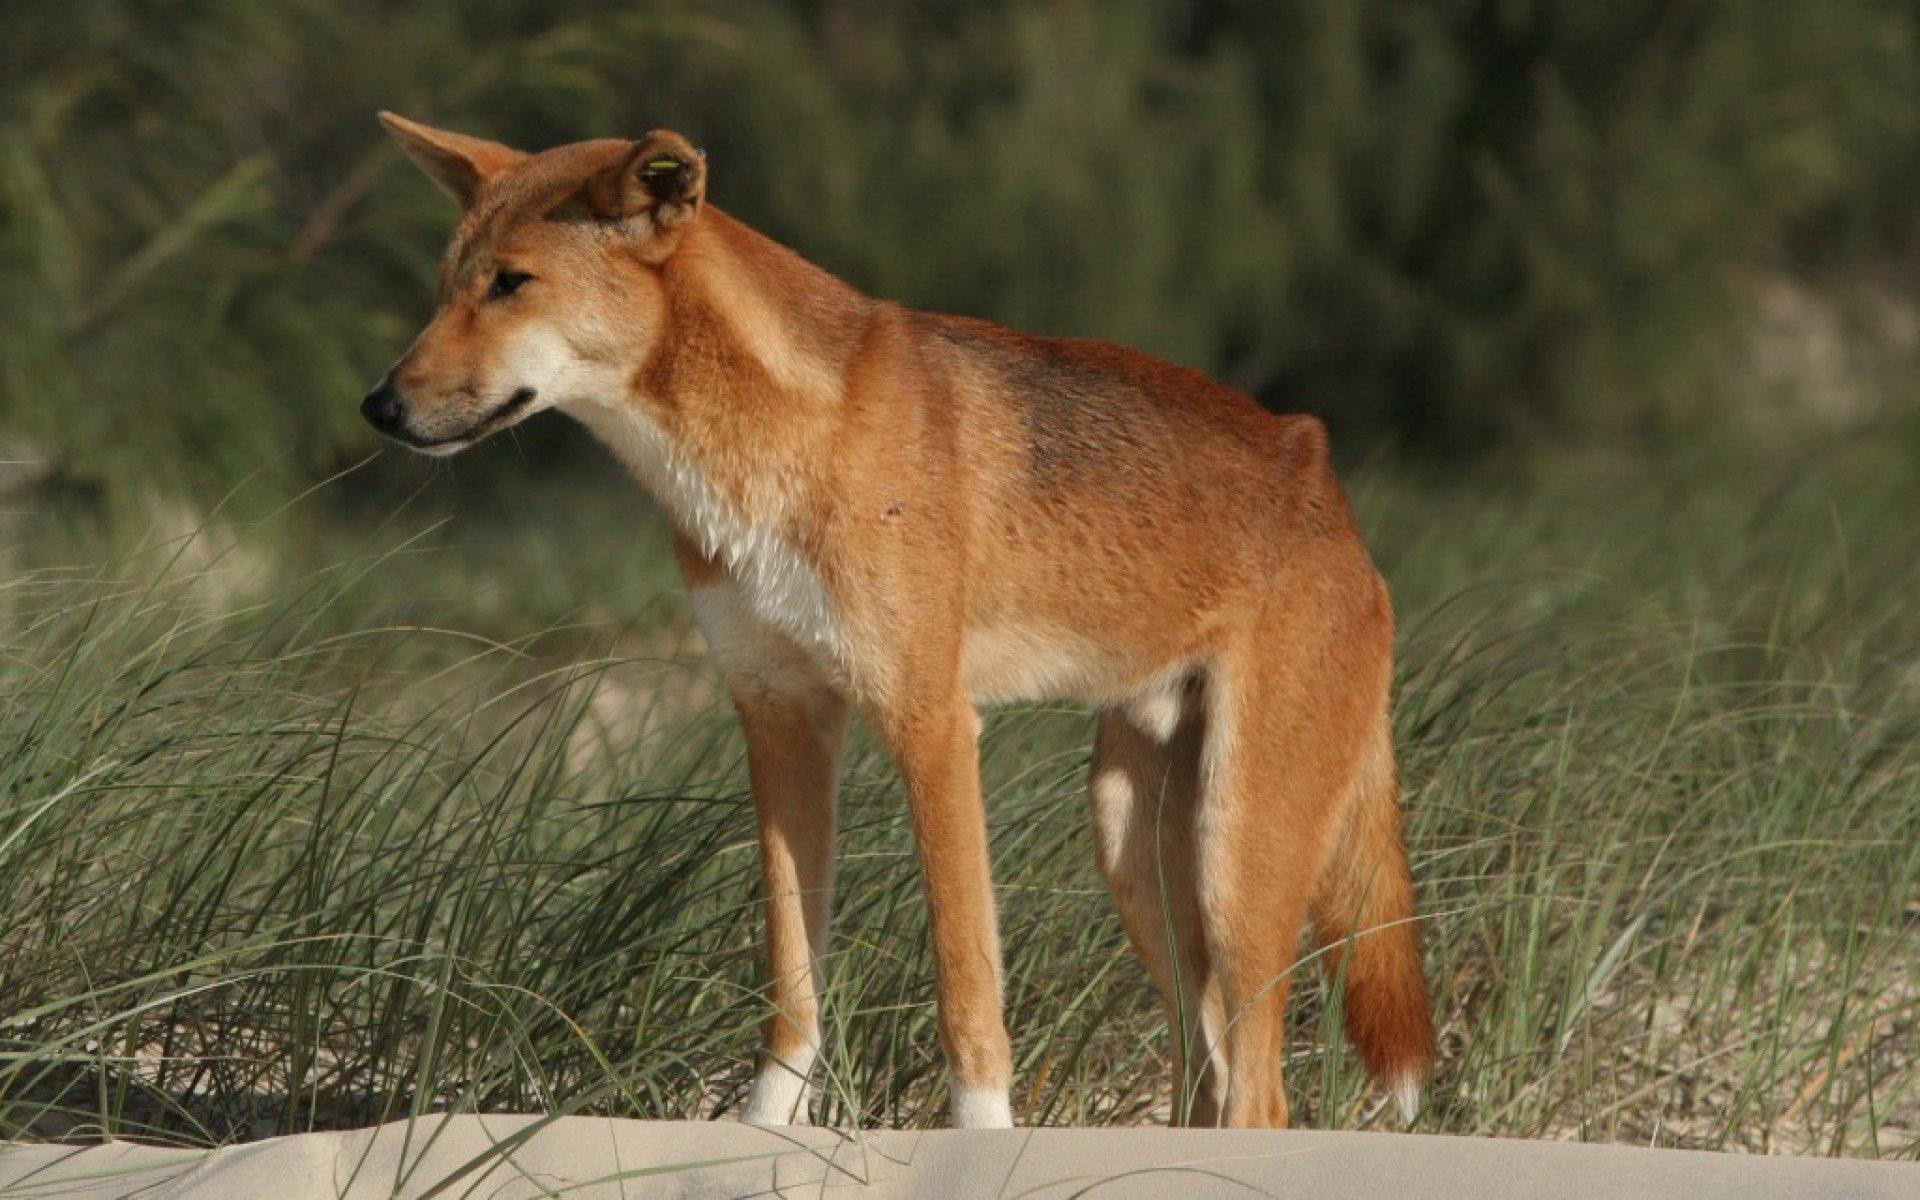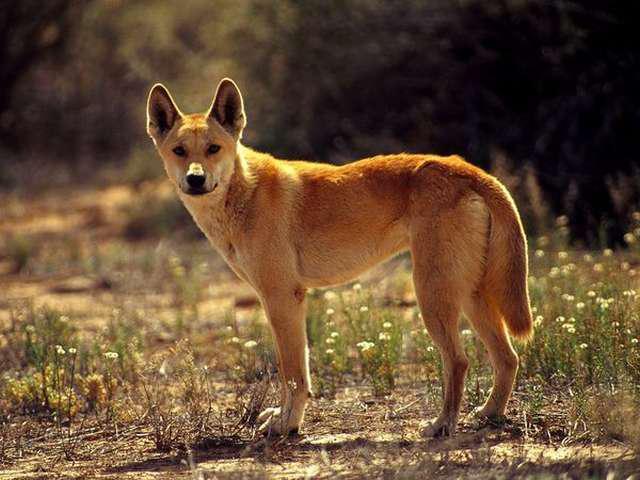The first image is the image on the left, the second image is the image on the right. For the images displayed, is the sentence "1 dingo is standing on all fours." factually correct? Answer yes or no. No. The first image is the image on the left, the second image is the image on the right. Examine the images to the left and right. Is the description "the animal in the image on the left is lying down" accurate? Answer yes or no. No. 